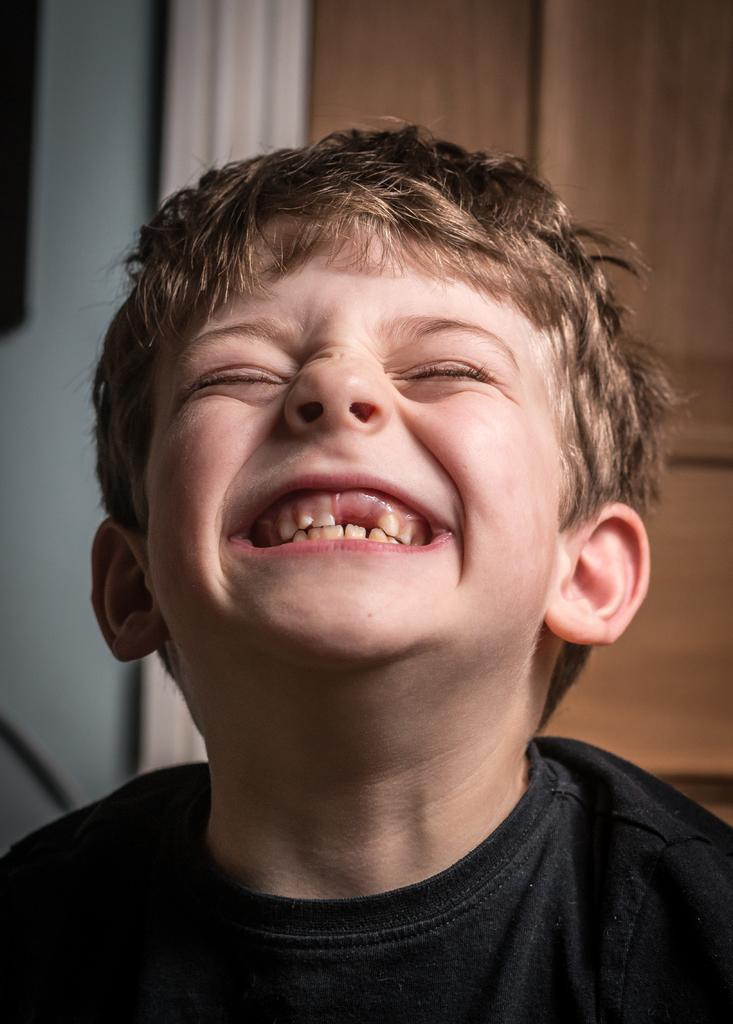What is the main subject of the image? The main subject of the image is a kid. What can be seen in the background of the image? There is a wall in the background of the image. What type of whistle can be heard in the image? There is no whistle present in the image, and therefore no sound can be heard. 